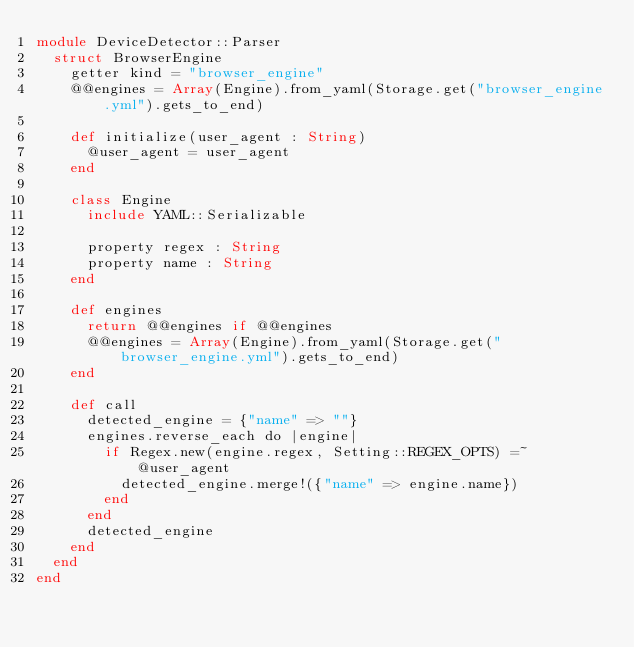Convert code to text. <code><loc_0><loc_0><loc_500><loc_500><_Crystal_>module DeviceDetector::Parser
  struct BrowserEngine
    getter kind = "browser_engine"
    @@engines = Array(Engine).from_yaml(Storage.get("browser_engine.yml").gets_to_end)

    def initialize(user_agent : String)
      @user_agent = user_agent
    end

    class Engine
      include YAML::Serializable

      property regex : String
      property name : String
    end

    def engines
      return @@engines if @@engines
      @@engines = Array(Engine).from_yaml(Storage.get("browser_engine.yml").gets_to_end)
    end

    def call
      detected_engine = {"name" => ""}
      engines.reverse_each do |engine|
        if Regex.new(engine.regex, Setting::REGEX_OPTS) =~ @user_agent
          detected_engine.merge!({"name" => engine.name})
        end
      end
      detected_engine
    end
  end
end
</code> 